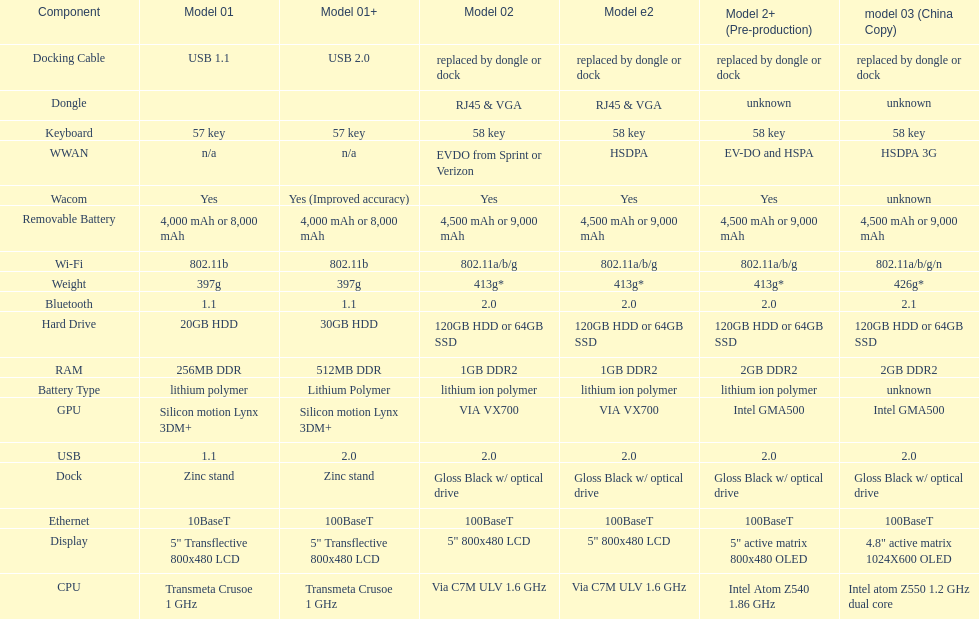Are there at least 13 different components on the chart? Yes. 